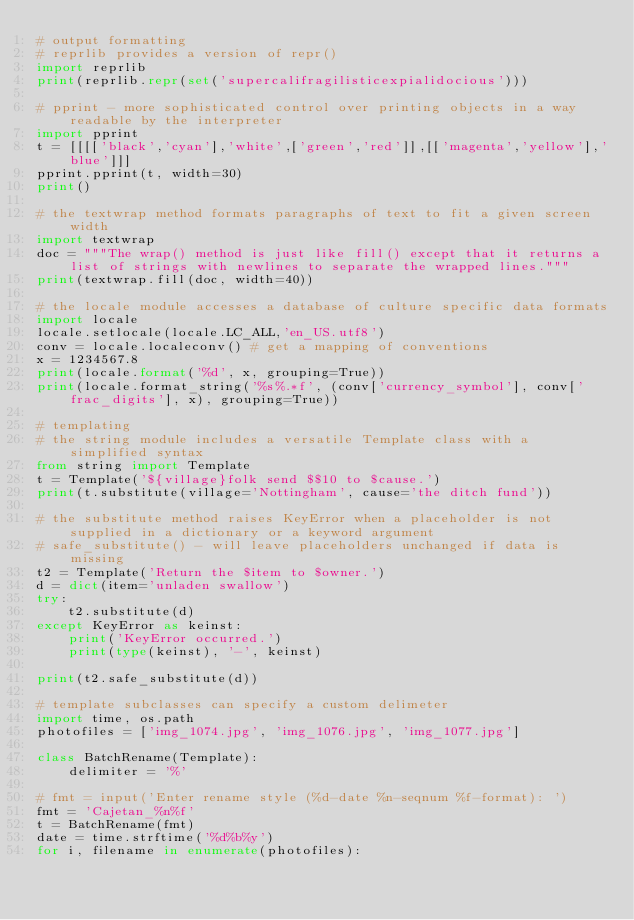<code> <loc_0><loc_0><loc_500><loc_500><_Python_># output formatting
# reprlib provides a version of repr()
import reprlib
print(reprlib.repr(set('supercalifragilisticexpialidocious')))

# pprint - more sophisticated control over printing objects in a way readable by the interpreter
import pprint
t = [[[['black','cyan'],'white',['green','red']],[['magenta','yellow'],'blue']]]
pprint.pprint(t, width=30)
print()

# the textwrap method formats paragraphs of text to fit a given screen width
import textwrap
doc = """The wrap() method is just like fill() except that it returns a list of strings with newlines to separate the wrapped lines."""
print(textwrap.fill(doc, width=40))

# the locale module accesses a database of culture specific data formats
import locale
locale.setlocale(locale.LC_ALL,'en_US.utf8')
conv = locale.localeconv() # get a mapping of conventions
x = 1234567.8
print(locale.format('%d', x, grouping=True))
print(locale.format_string('%s%.*f', (conv['currency_symbol'], conv['frac_digits'], x), grouping=True))

# templating
# the string module includes a versatile Template class with a simplified syntax
from string import Template
t = Template('${village}folk send $$10 to $cause.')
print(t.substitute(village='Nottingham', cause='the ditch fund'))

# the substitute method raises KeyError when a placeholder is not supplied in a dictionary or a keyword argument
# safe_substitute() - will leave placeholders unchanged if data is missing
t2 = Template('Return the $item to $owner.')
d = dict(item='unladen swallow')
try:
    t2.substitute(d)
except KeyError as keinst:
    print('KeyError occurred.')
    print(type(keinst), '-', keinst)

print(t2.safe_substitute(d))

# template subclasses can specify a custom delimeter
import time, os.path
photofiles = ['img_1074.jpg', 'img_1076.jpg', 'img_1077.jpg']

class BatchRename(Template):
    delimiter = '%'

# fmt = input('Enter rename style (%d-date %n-seqnum %f-format): ')
fmt = 'Cajetan_%n%f'
t = BatchRename(fmt)
date = time.strftime('%d%b%y')
for i, filename in enumerate(photofiles):</code> 